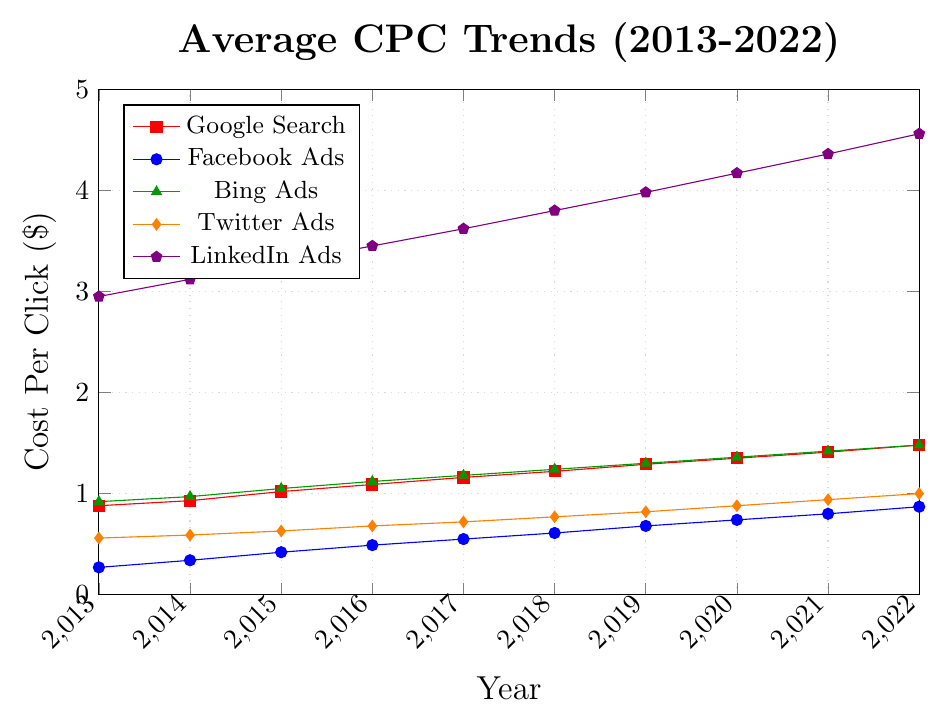Which platform saw the highest average CPC in 2022? By looking at the end of each trend line in 2022, LinkedIn Ads shows the highest value, around $4.56
Answer: LinkedIn Ads Which platform had the lowest average CPC in 2014? By examining the data points for 2014, Facebook Ads had the lowest average CPC at $0.34
Answer: Facebook Ads What is the difference in average CPC between Twitter Ads and Google Search in 2020? The CPC for Twitter Ads in 2020 is $0.88, and for Google Search it's $1.35. The difference is $1.35 - $0.88 = $0.47
Answer: $0.47 Has Facebook Ads' average CPC grown faster or slower than Bing Ads from 2013 to 2022? To determine the growth rate, compare the initial and final values for both platforms. Facebook Ads grew from $0.27 to $0.87 ($0.60 increase), while Bing Ads grew from $0.92 to $1.48 ($0.56 increase). Since $0.60 > $0.56, Facebook Ads grew faster
Answer: Faster What was the average CPC for LinkedIn Ads over the last decade? Sum LinkedIn Ads values and divide by the number of years: $(2.95 + 3.12 + 3.28 + 3.45 + 3.62 + 3.80 + 3.98 + 4.17 + 4.36 + 4.56)/10$ = $37.29/10$ = $3.73
Answer: $3.73 Between 2013 and 2018, which platform had the most consistent average CPC? Consistency implies the least fluctuation. Compare the trends for all platforms: Facebook Ads grow steadily from $0.27 in 2013 to $0.61 in 2018, indicating the least fluctuation
Answer: Facebook Ads Which year saw the biggest increase in average CPC for Google Search? Identify year-on-year differences for Google Search: 2013 to 2014(0.05), 2014 to 2015(0.09), 2015 to 2016(0.07), 2016 to 2017(0.07), 2017 to 2018(0.06), 2018 to 2019(0.07), 2019 to 2020(0.06), 2020 to 2021(0.06), 2021 to 2022(0.07). The largest increase is from 2014 to 2015
Answer: 2014 to 2015 What is the combined average CPC for all platforms in 2021? Sum the CPC values: $1.41 + 0.80 + 1.42 + 0.94 + 4.36$ = $8.93
Answer: $8.93 Which platforms had an average CPC greater than $3 in any year? Observing the values, LinkedIn Ads had an average CPC greater than $3 in every year from 2013 to 2022
Answer: LinkedIn Ads 